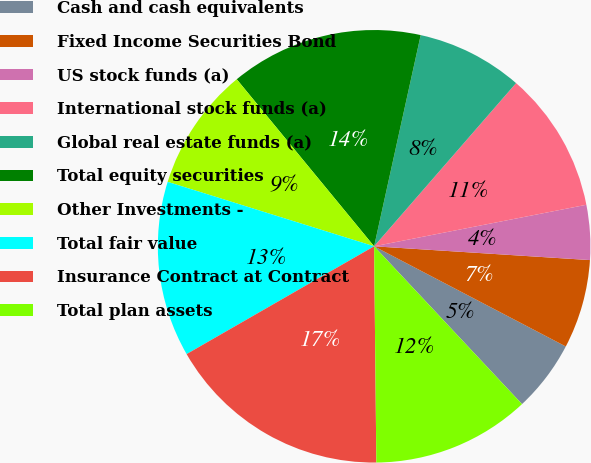Convert chart. <chart><loc_0><loc_0><loc_500><loc_500><pie_chart><fcel>Cash and cash equivalents<fcel>Fixed Income Securities Bond<fcel>US stock funds (a)<fcel>International stock funds (a)<fcel>Global real estate funds (a)<fcel>Total equity securities<fcel>Other Investments -<fcel>Total fair value<fcel>Insurance Contract at Contract<fcel>Total plan assets<nl><fcel>5.35%<fcel>6.65%<fcel>4.09%<fcel>10.53%<fcel>7.94%<fcel>14.41%<fcel>9.23%<fcel>13.12%<fcel>16.86%<fcel>11.82%<nl></chart> 